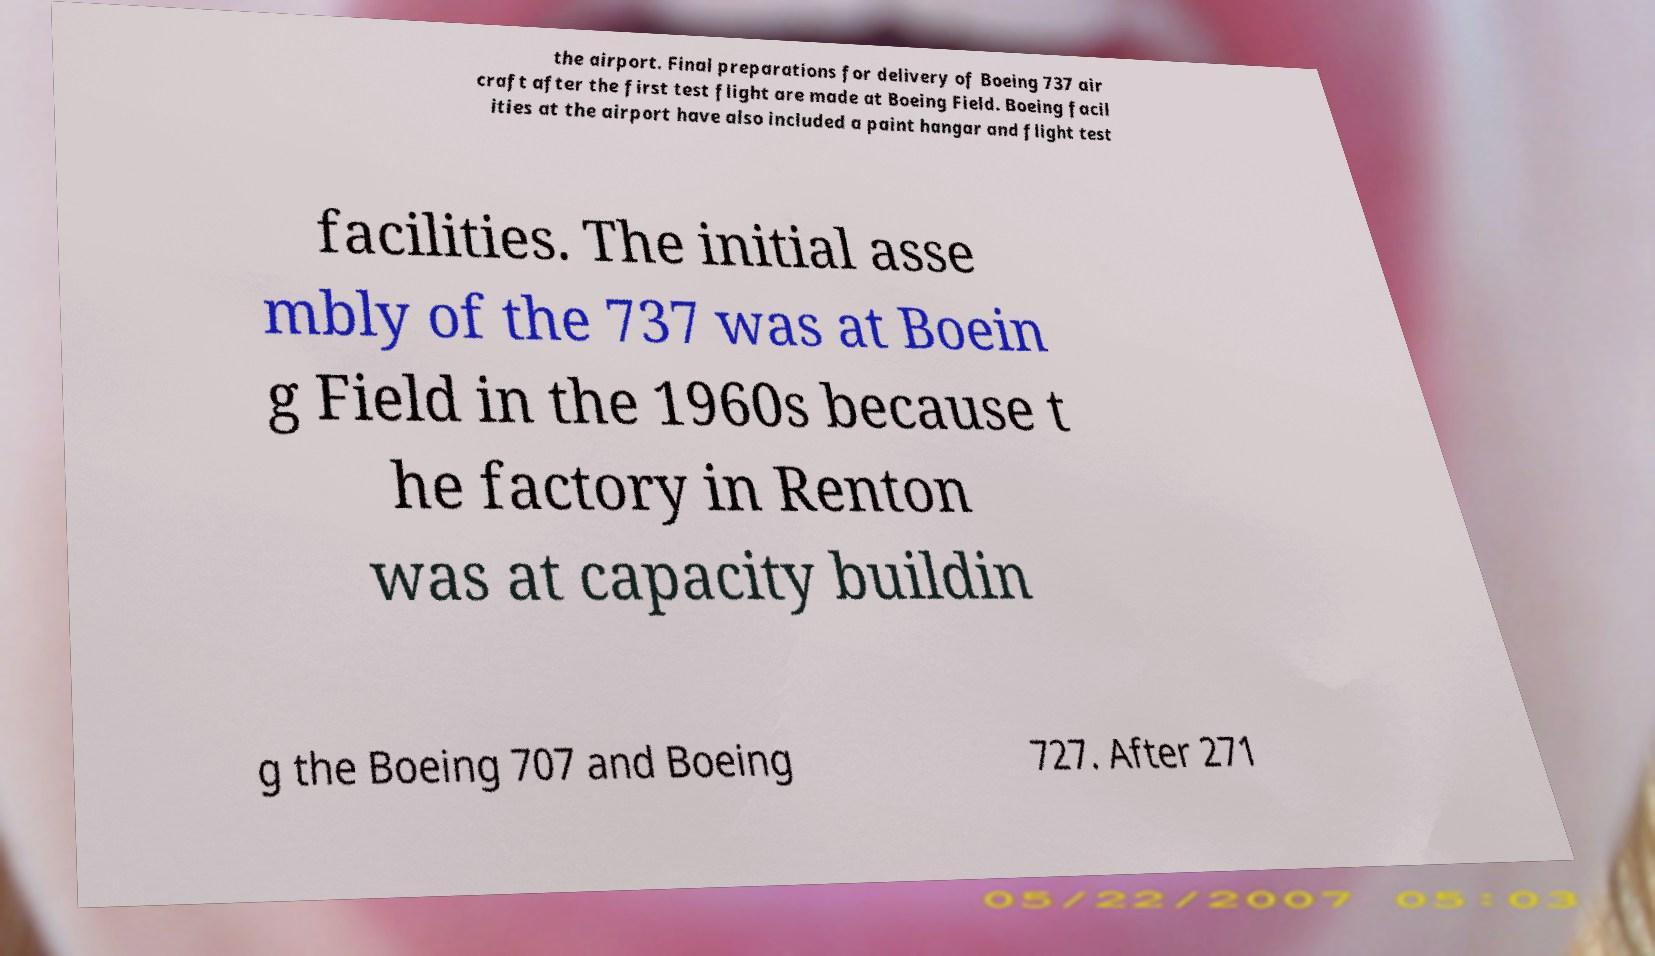I need the written content from this picture converted into text. Can you do that? the airport. Final preparations for delivery of Boeing 737 air craft after the first test flight are made at Boeing Field. Boeing facil ities at the airport have also included a paint hangar and flight test facilities. The initial asse mbly of the 737 was at Boein g Field in the 1960s because t he factory in Renton was at capacity buildin g the Boeing 707 and Boeing 727. After 271 